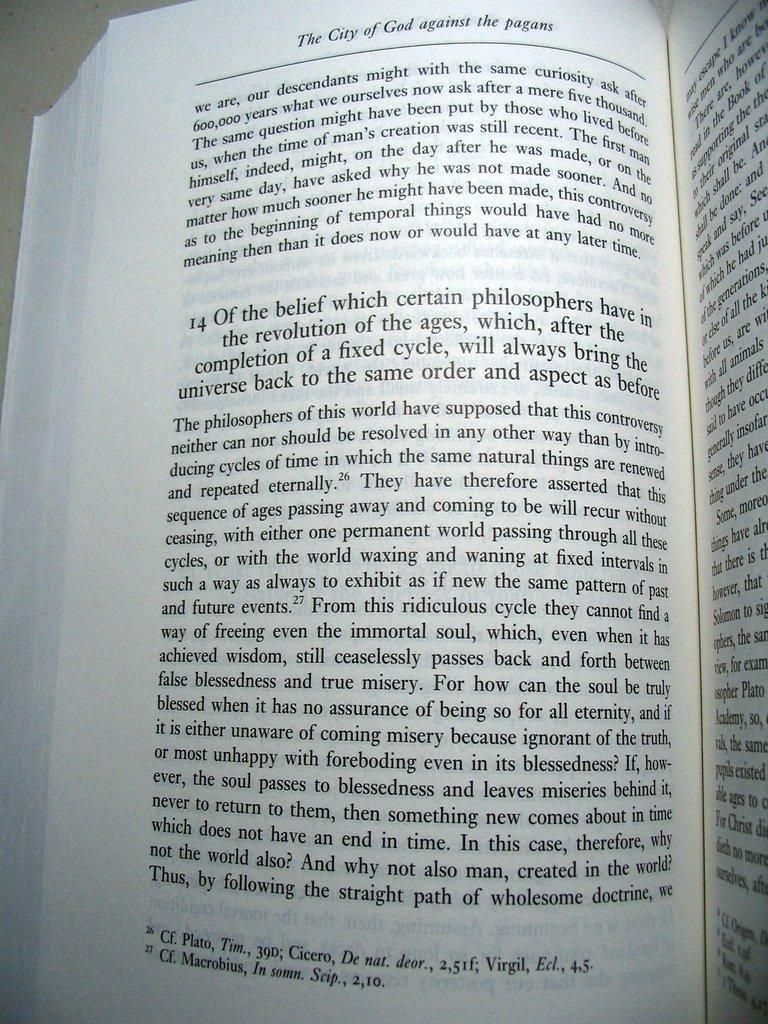<image>
Offer a succinct explanation of the picture presented. A philosophy book about the revolution of ages is open on a table. 